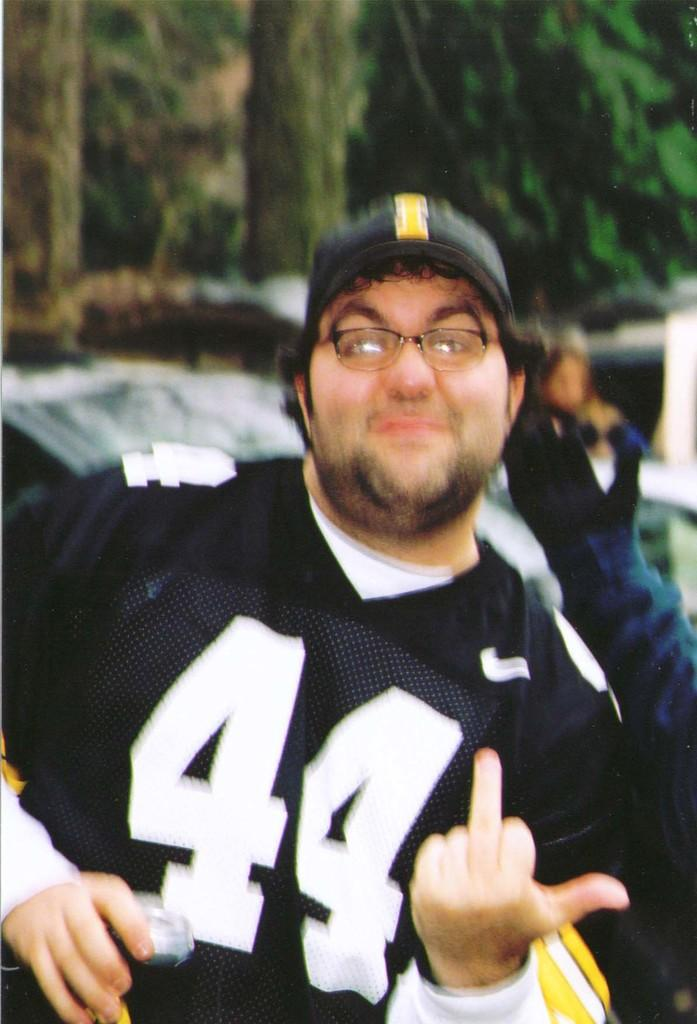Who is present in the image? There is a man in the image. What is the man wearing on his upper body? The man is wearing a black T-shirt. What type of headwear is the man wearing? The man is wearing a black cap. Can you describe the background of the image? There is a person in the background of the image, and many trees are visible. What type of lace can be seen on the man's clothing in the image? There is no lace visible on the man's clothing in the image; he is wearing a black T-shirt and cap. What is the man laughing about in the image? The man's facial expression is not visible in the image, so it cannot be determined if he is laughing or not. 